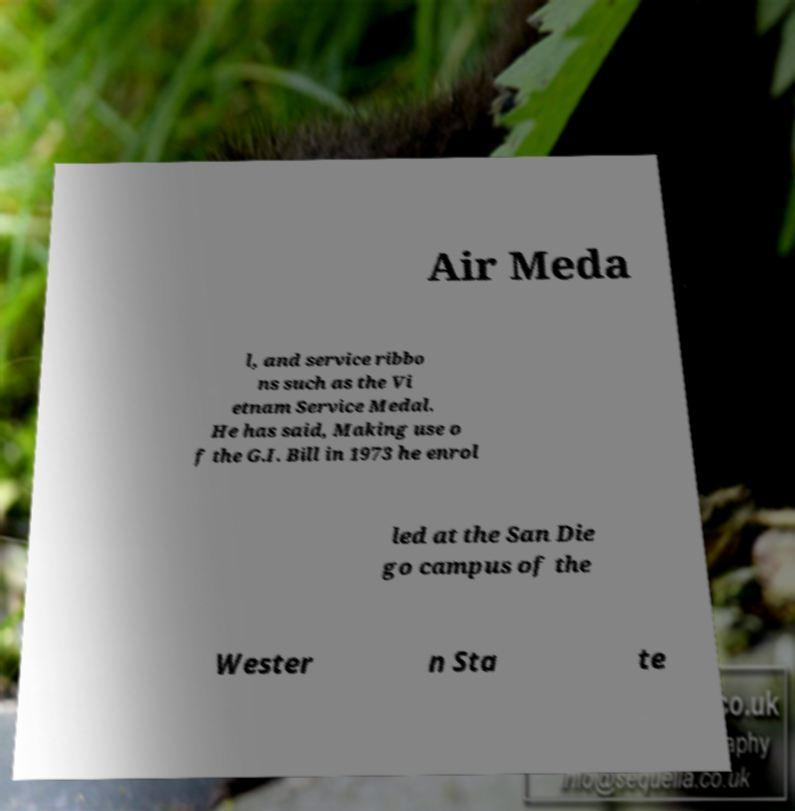Can you accurately transcribe the text from the provided image for me? Air Meda l, and service ribbo ns such as the Vi etnam Service Medal. He has said, Making use o f the G.I. Bill in 1973 he enrol led at the San Die go campus of the Wester n Sta te 